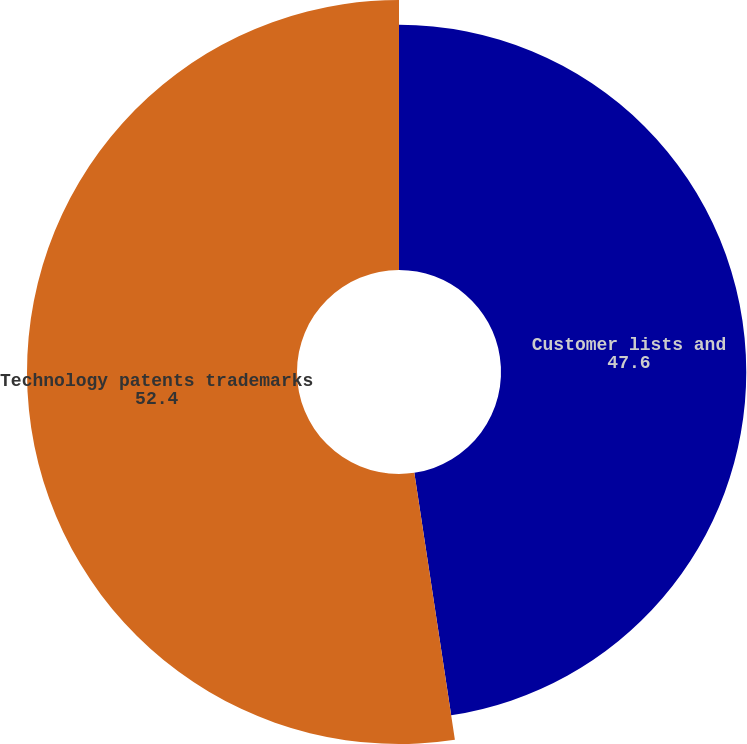<chart> <loc_0><loc_0><loc_500><loc_500><pie_chart><fcel>Customer lists and<fcel>Technology patents trademarks<nl><fcel>47.6%<fcel>52.4%<nl></chart> 